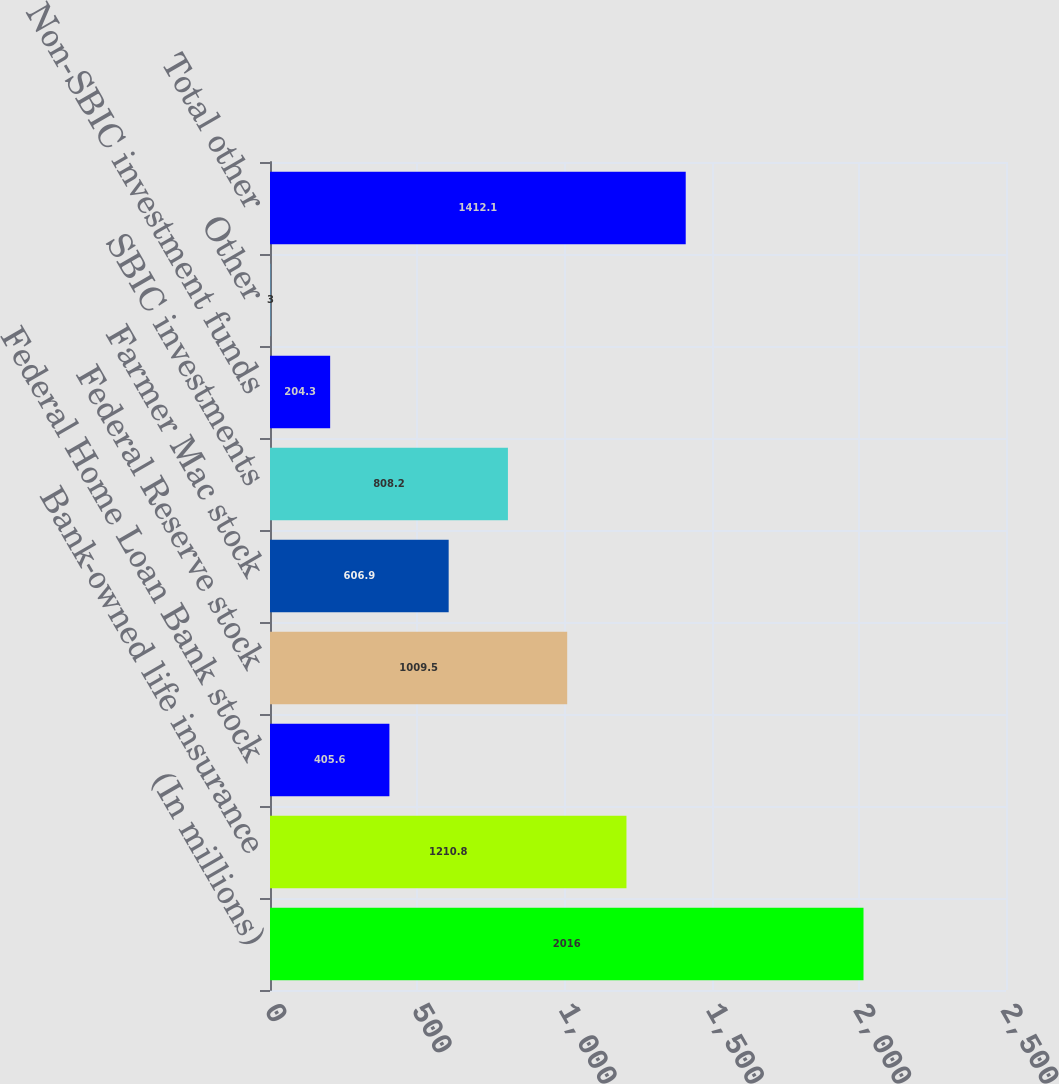Convert chart. <chart><loc_0><loc_0><loc_500><loc_500><bar_chart><fcel>(In millions)<fcel>Bank-owned life insurance<fcel>Federal Home Loan Bank stock<fcel>Federal Reserve stock<fcel>Farmer Mac stock<fcel>SBIC investments<fcel>Non-SBIC investment funds<fcel>Other<fcel>Total other<nl><fcel>2016<fcel>1210.8<fcel>405.6<fcel>1009.5<fcel>606.9<fcel>808.2<fcel>204.3<fcel>3<fcel>1412.1<nl></chart> 